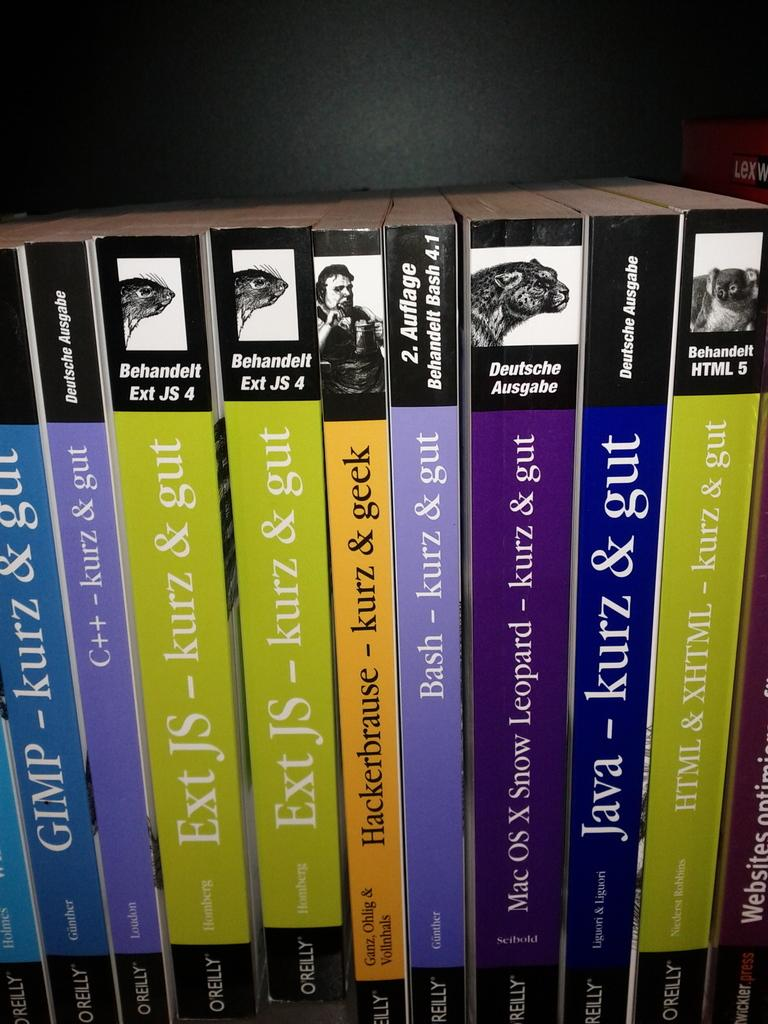<image>
Relay a brief, clear account of the picture shown. A row of green and blue books that say Ext JS - kurz & gut. 